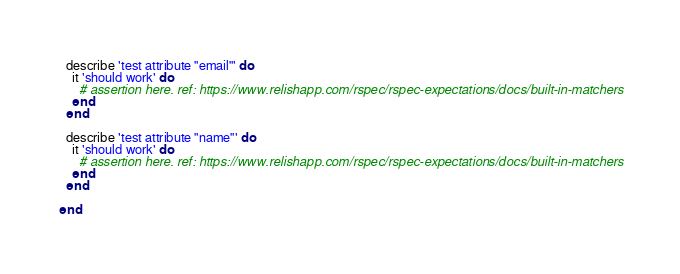<code> <loc_0><loc_0><loc_500><loc_500><_Ruby_>  describe 'test attribute "email"' do
    it 'should work' do
      # assertion here. ref: https://www.relishapp.com/rspec/rspec-expectations/docs/built-in-matchers
    end
  end

  describe 'test attribute "name"' do
    it 'should work' do
      # assertion here. ref: https://www.relishapp.com/rspec/rspec-expectations/docs/built-in-matchers
    end
  end

end
</code> 